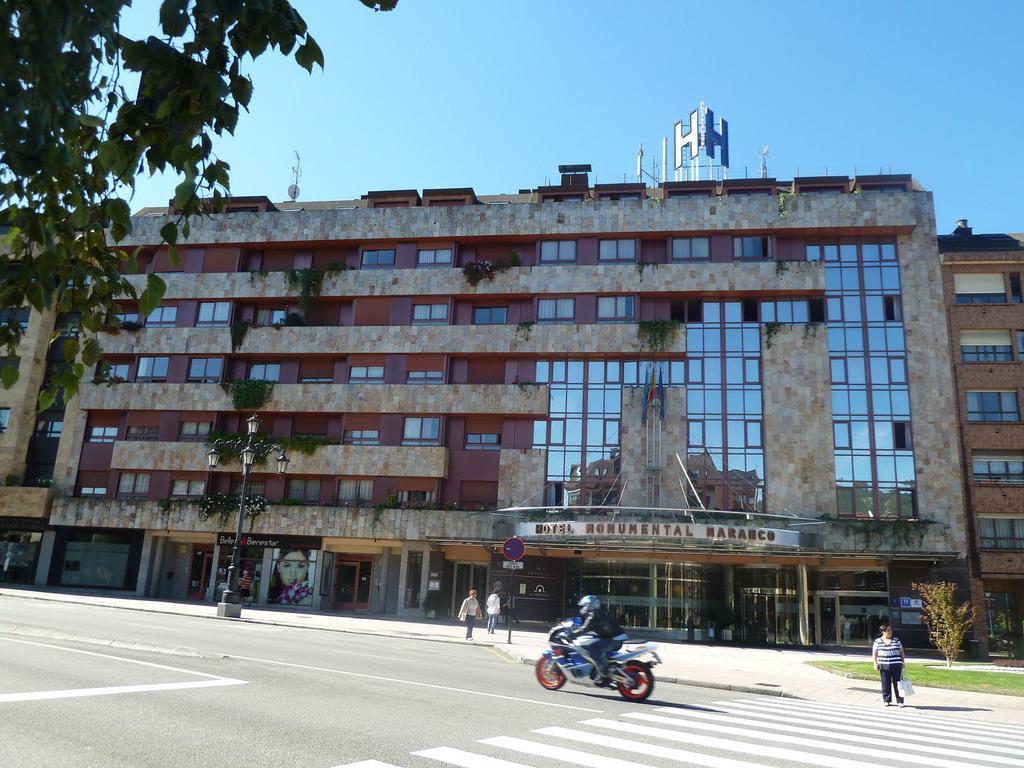Could you give a brief overview of what you see in this image? In this image a person is riding the bike on the road having few zebra crossing lines on it. There is a person standing on the pavement. Few persons are walking on the pavement. There is a street light. There is grassland having a plant on it. Behind there are buildings having few plants in the balcony. Top of image there is sky. Left top there are few leaves to the branches. 